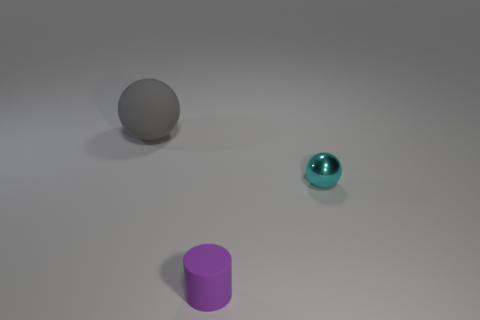Add 2 cyan shiny spheres. How many objects exist? 5 Subtract all spheres. How many objects are left? 1 Add 2 big matte spheres. How many big matte spheres are left? 3 Add 3 yellow rubber spheres. How many yellow rubber spheres exist? 3 Subtract 0 brown blocks. How many objects are left? 3 Subtract all gray matte spheres. Subtract all gray rubber things. How many objects are left? 1 